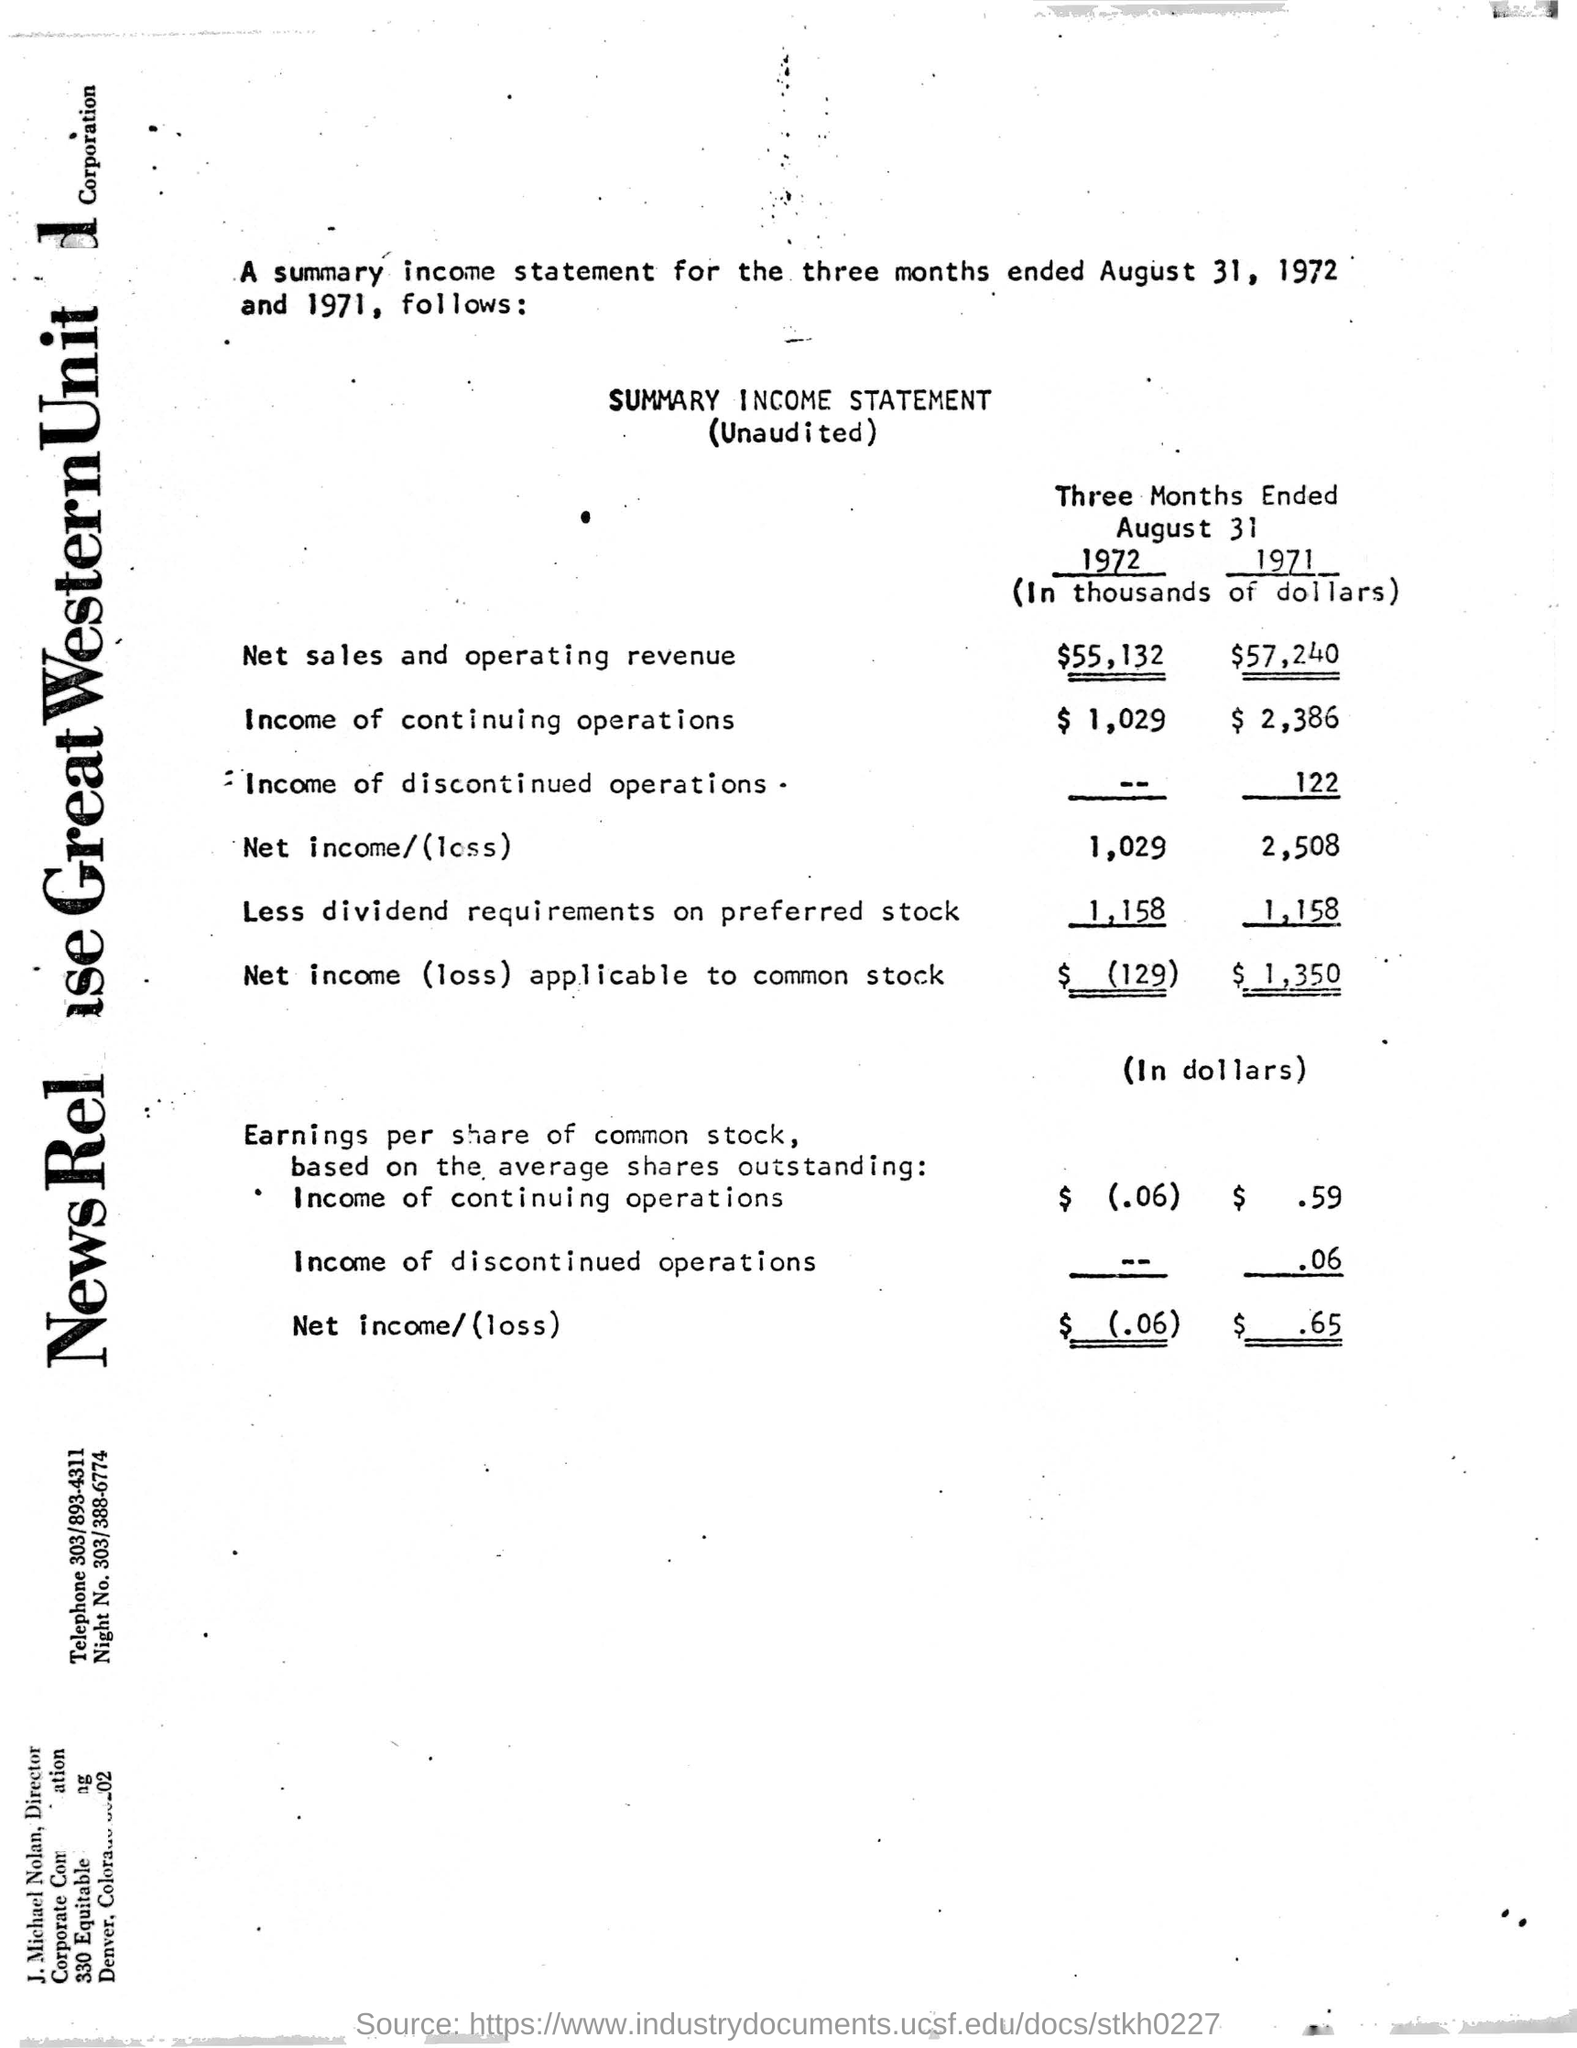Mention a couple of crucial points in this snapshot. The net income (loss) applicable to common stock for the three months ended August 31, 1971, was $1,350. For the three months ended August 31, 1971, the income from continuing operations was $2,386. The net sales and operating revenue for the three months ended August 31, 1972, amounted to $55,132. The net sales and operating revenue for the three months ended August 31, 1971, was $57,240. The income from continuing operations for the three months ended August 31, 1972 was $1,029. 